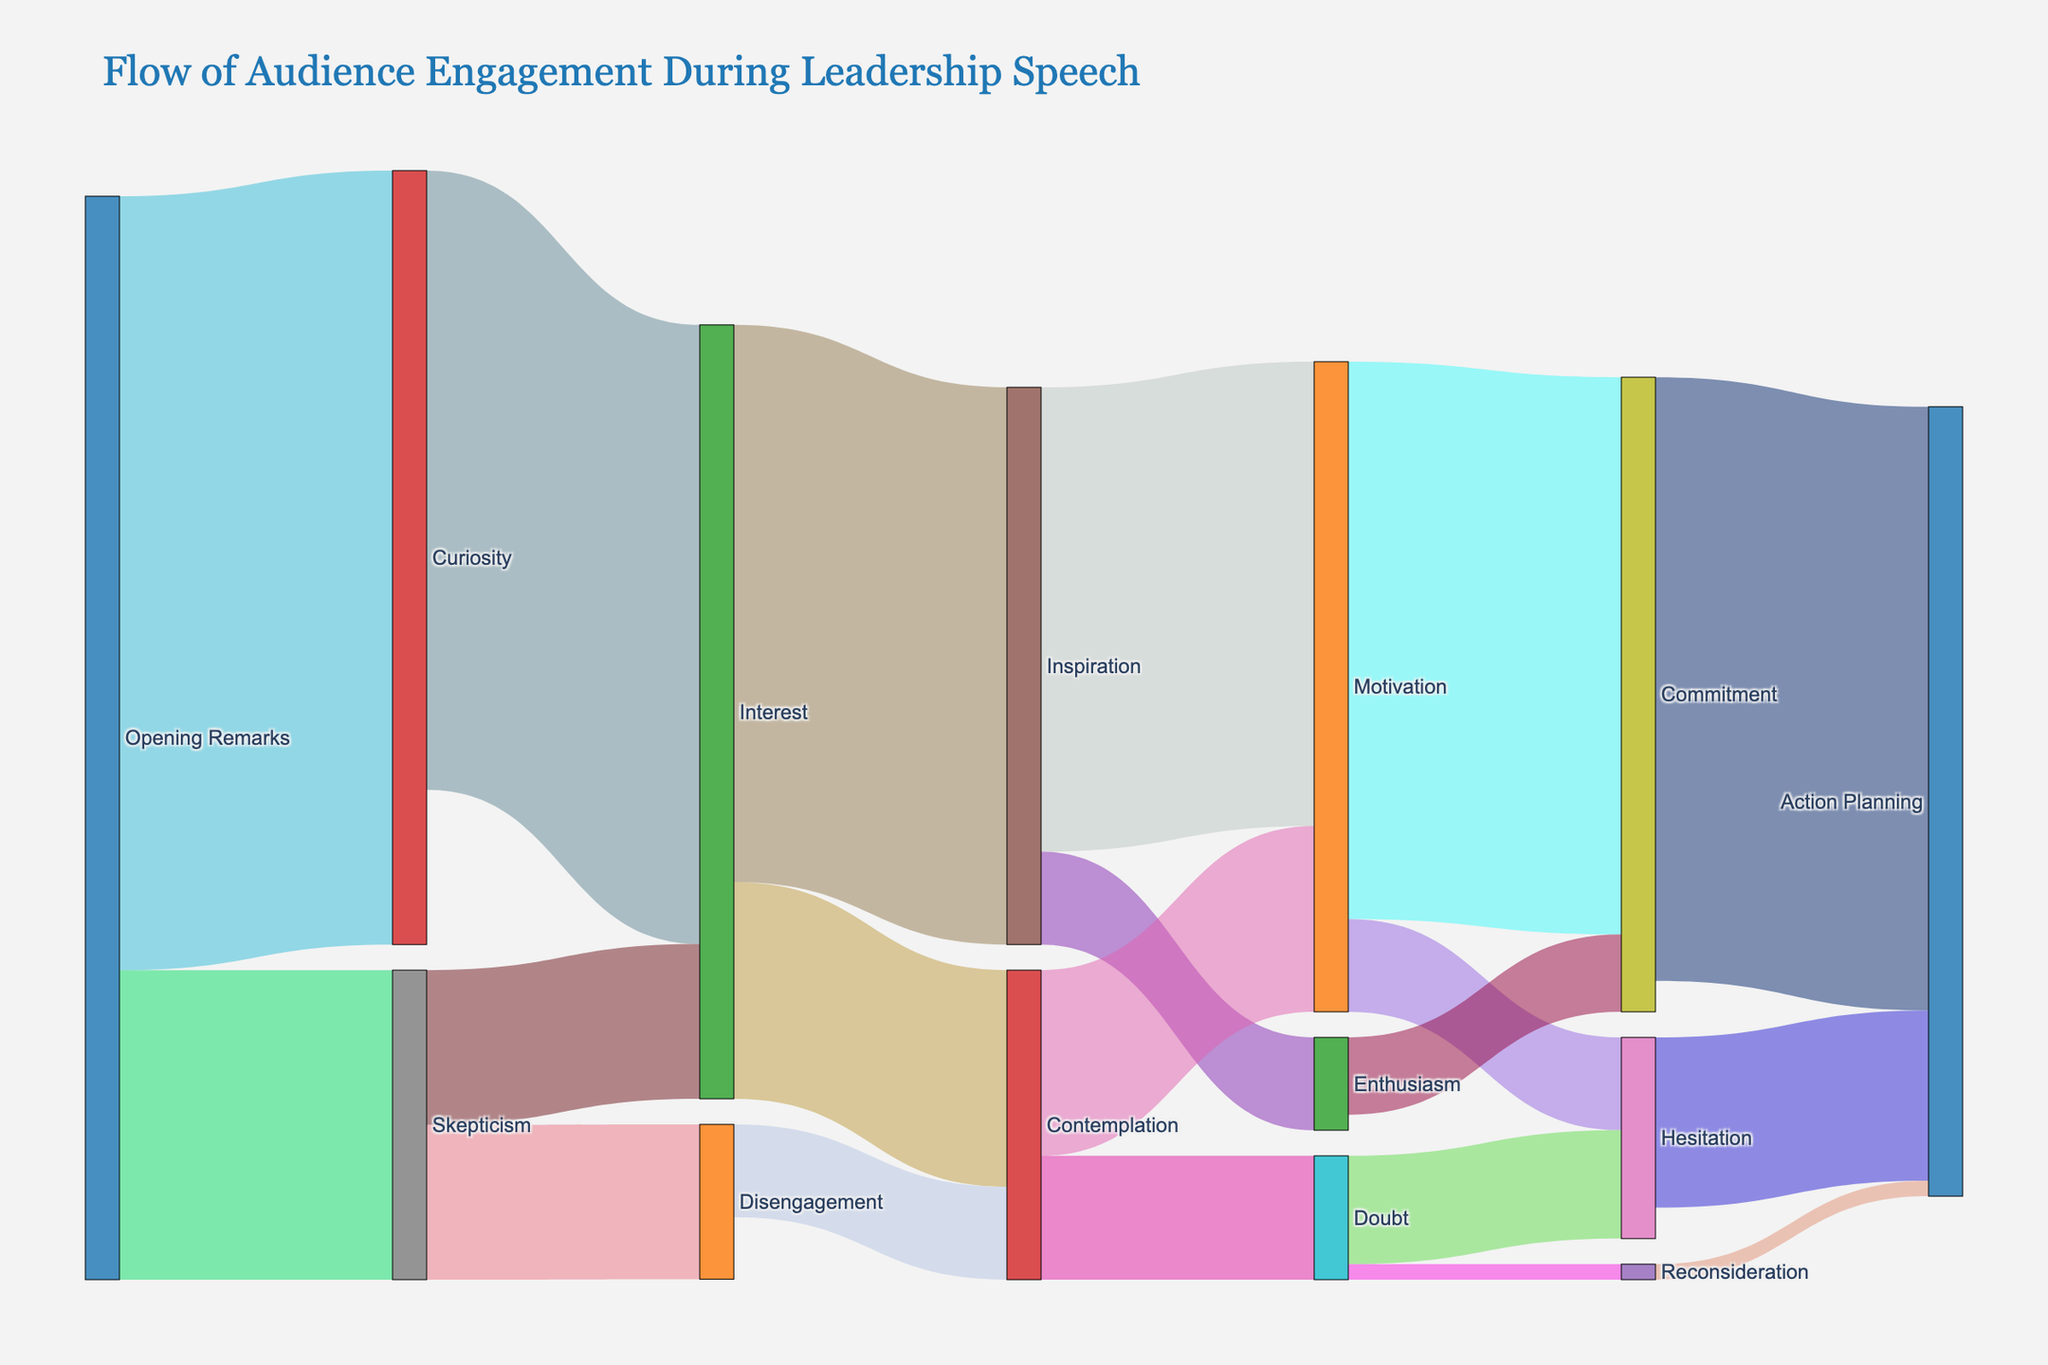What emotional states do the audience transition into after the opening remarks? The Sankey diagram shows that the audience transitions from the opening remarks into curiosity and skepticism.
Answer: Curiosity, Skepticism Which emotional state receives the most transitions from curiosity? From curiosity, the most significant transitions lead to interest, as indicated by the larger flow.
Answer: Interest What is the total number of individuals who moved from interest to other states? The Sankey diagram shows flows of 180 to inspiration and 70 to contemplation from interest. Adding these gives the total number.
Answer: 250 Compare the transition values from skepticism to interest and disengagement. Which is higher? The Sankey diagram shows a flow of 50 from skepticism to interest and a flow of 50 from skepticism to disengagement.
Answer: Equal What is the final emotional state with the highest number of individuals? The final states include action planning, commitment, hesitation, reconsideration. By adding the inflows, action planning has the highest number.
Answer: Action Planning How many individuals moved from inspiration to motivation? The Sankey diagram shows a flow of 150 moving from inspiration to motivation.
Answer: 150 What is the overall proportion of the first transitions (from opening remarks) that resulted in curiosity relative to the total from opening remarks? There are 250 to curiosity and 100 to skepticism. The proportion is 250/(250+100).
Answer: 5/7 (or approximately 71.4%) What proportion of individuals who showed doubt ended up in hesitation? From doubt, 35 moved to hesitation out of a total of 40 + 5 = 45, so the proportion is 35/45.
Answer: 7/9 (or approximately 77.8%) What stage followed inspiration by the second largest number of individuals? The Sankey diagram shows that the second highest number of individuals from inspiration moved to enthusiasm.
Answer: Enthusiasm Where do individuals in the disengagement state eventually transition to? From the disengagement state, individuals move to contemplation as shown by a flow of 30.
Answer: Contemplation 